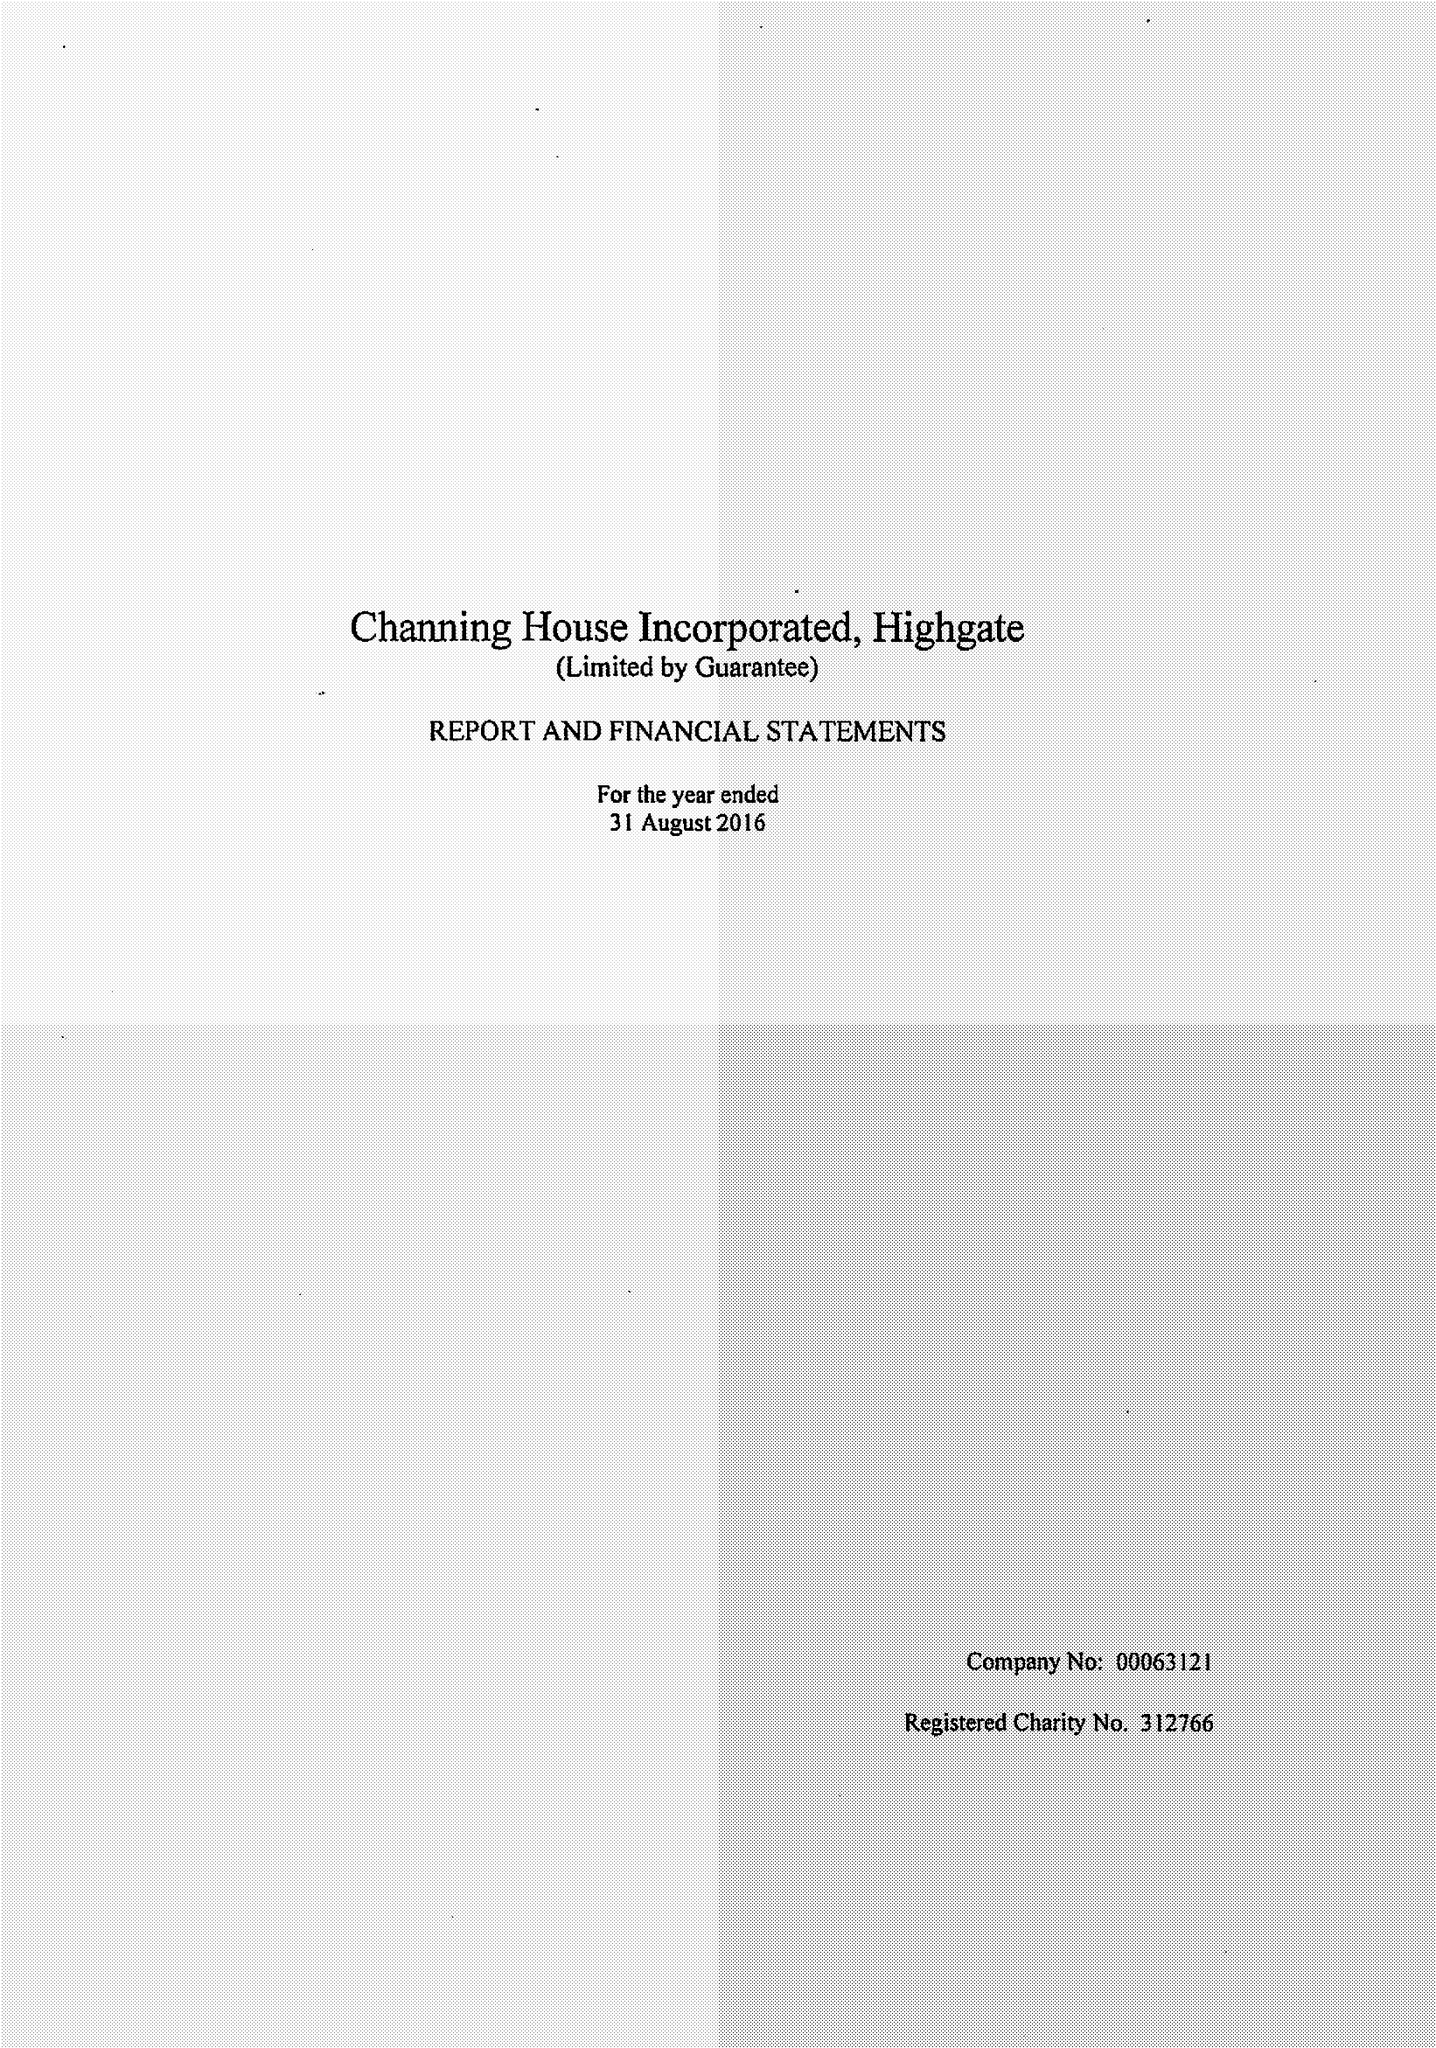What is the value for the spending_annually_in_british_pounds?
Answer the question using a single word or phrase. 11985500.00 